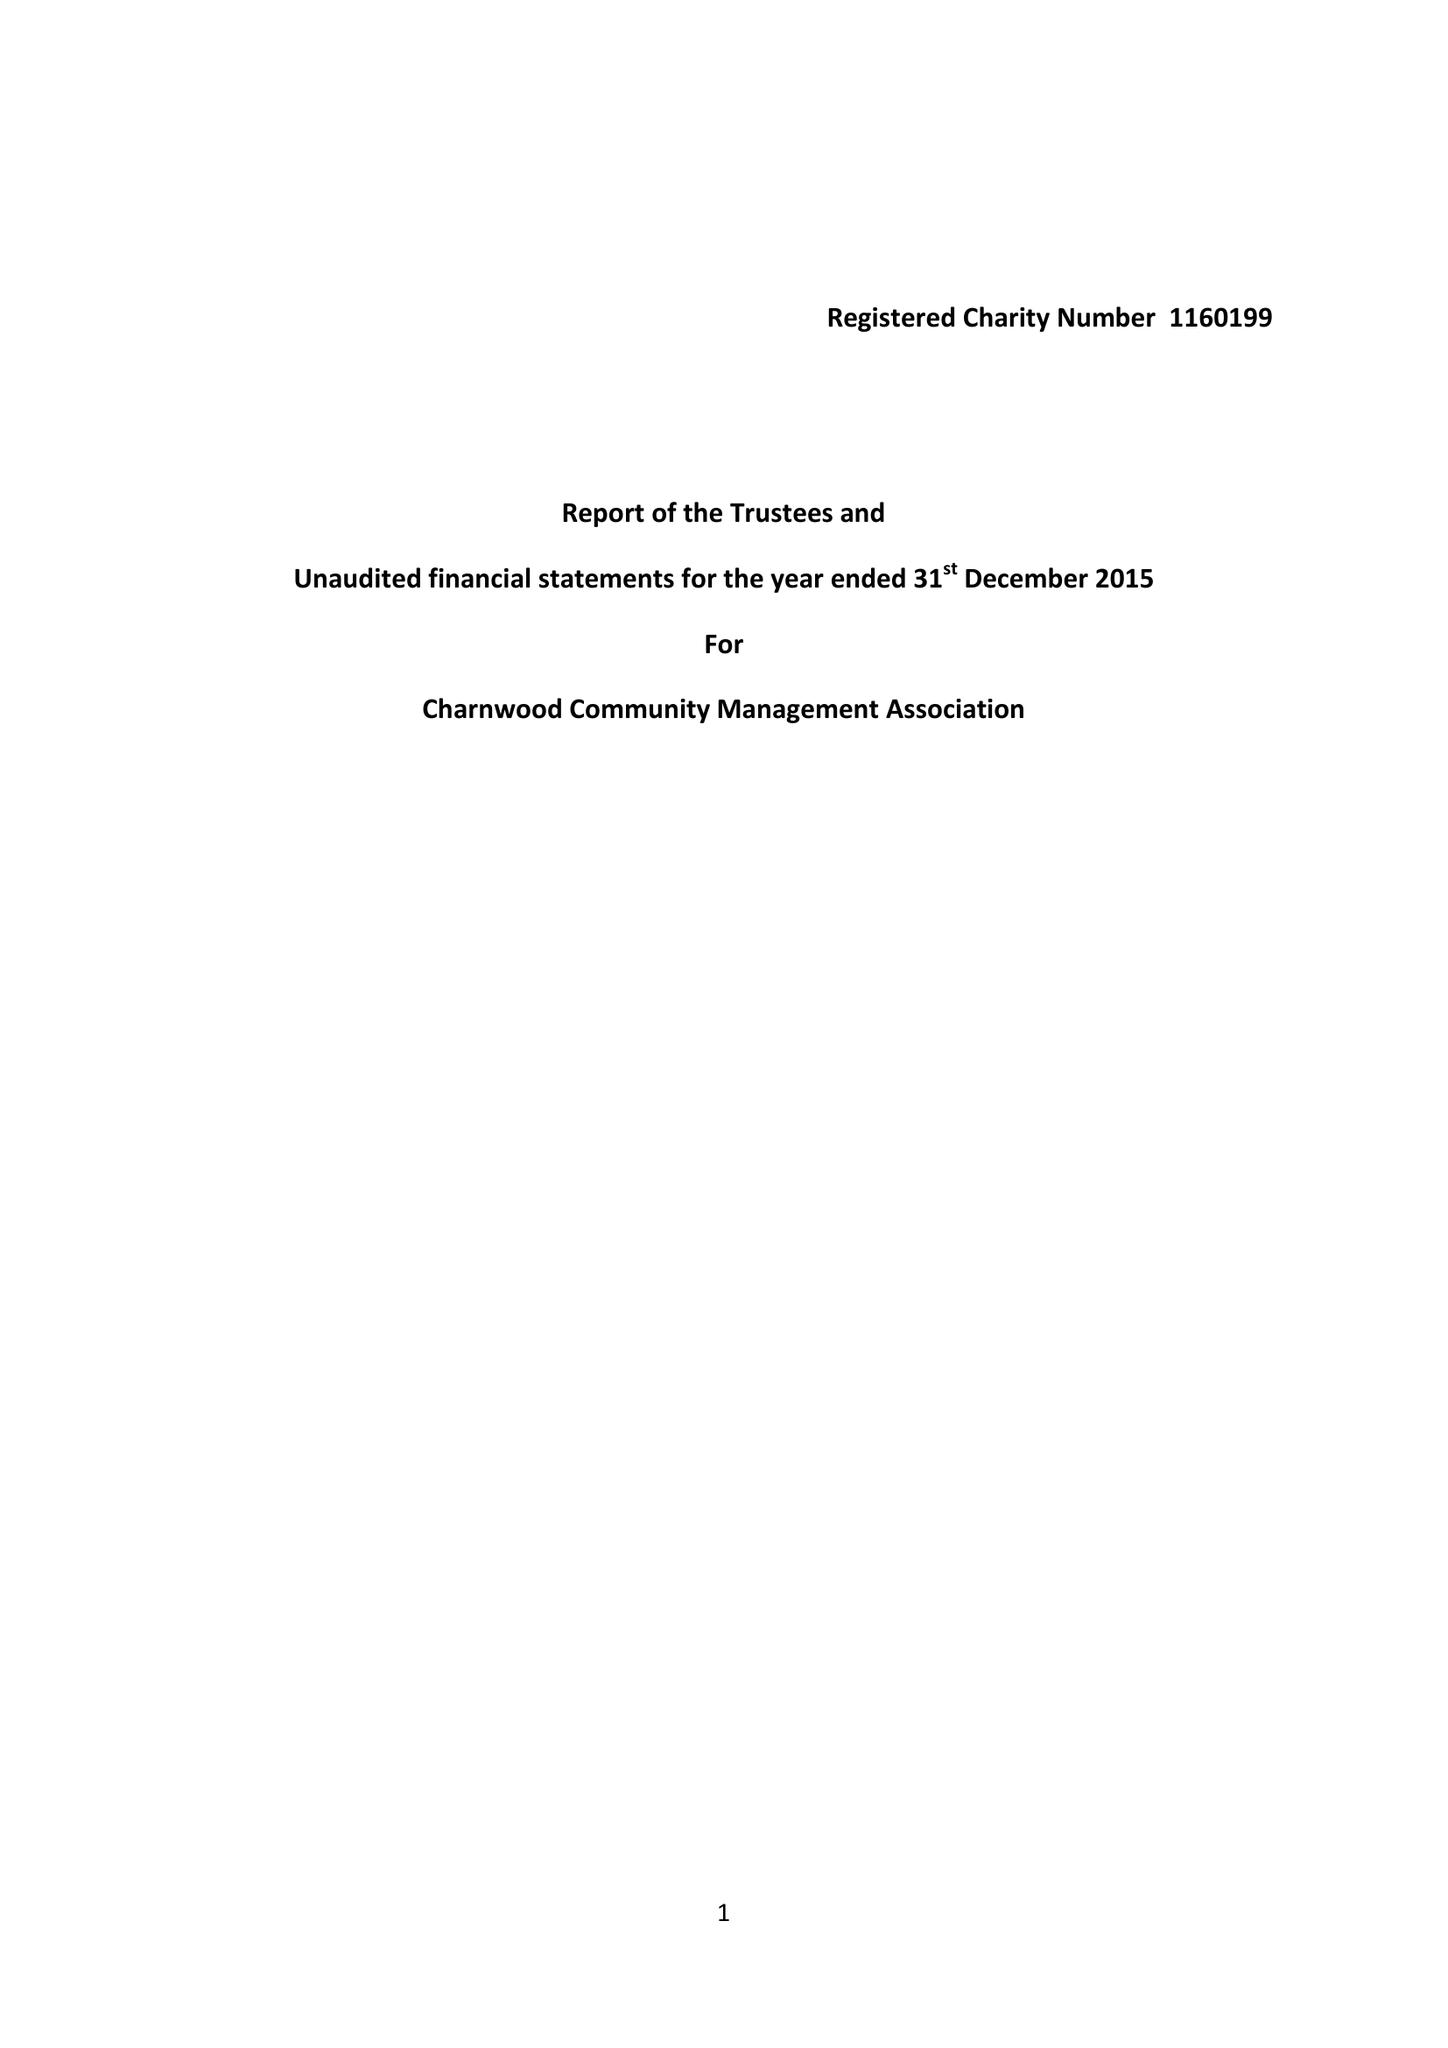What is the value for the spending_annually_in_british_pounds?
Answer the question using a single word or phrase. 2184.67 